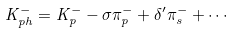Convert formula to latex. <formula><loc_0><loc_0><loc_500><loc_500>K ^ { - } _ { p h } = K ^ { - } _ { p } - \sigma \pi ^ { - } _ { p } + \delta ^ { \prime } \pi ^ { - } _ { s } + \cdots</formula> 